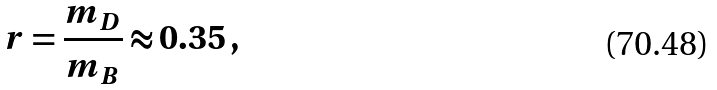<formula> <loc_0><loc_0><loc_500><loc_500>r = \frac { m _ { D } } { m _ { B } } \approx 0 . 3 5 \, ,</formula> 